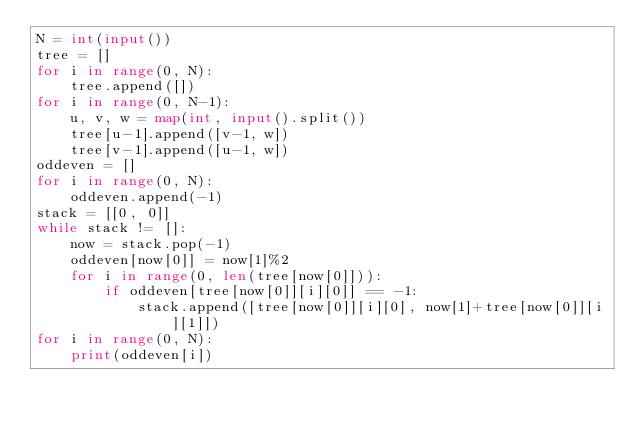Convert code to text. <code><loc_0><loc_0><loc_500><loc_500><_Python_>N = int(input())
tree = []
for i in range(0, N):
	tree.append([])
for i in range(0, N-1):
	u, v, w = map(int, input().split())
	tree[u-1].append([v-1, w])
	tree[v-1].append([u-1, w])
oddeven = []
for i in range(0, N):
	oddeven.append(-1)
stack = [[0, 0]]
while stack != []:
	now = stack.pop(-1)
	oddeven[now[0]] = now[1]%2
	for i in range(0, len(tree[now[0]])):
		if oddeven[tree[now[0]][i][0]] == -1:
			stack.append([tree[now[0]][i][0], now[1]+tree[now[0]][i][1]])
for i in range(0, N):
	print(oddeven[i])</code> 